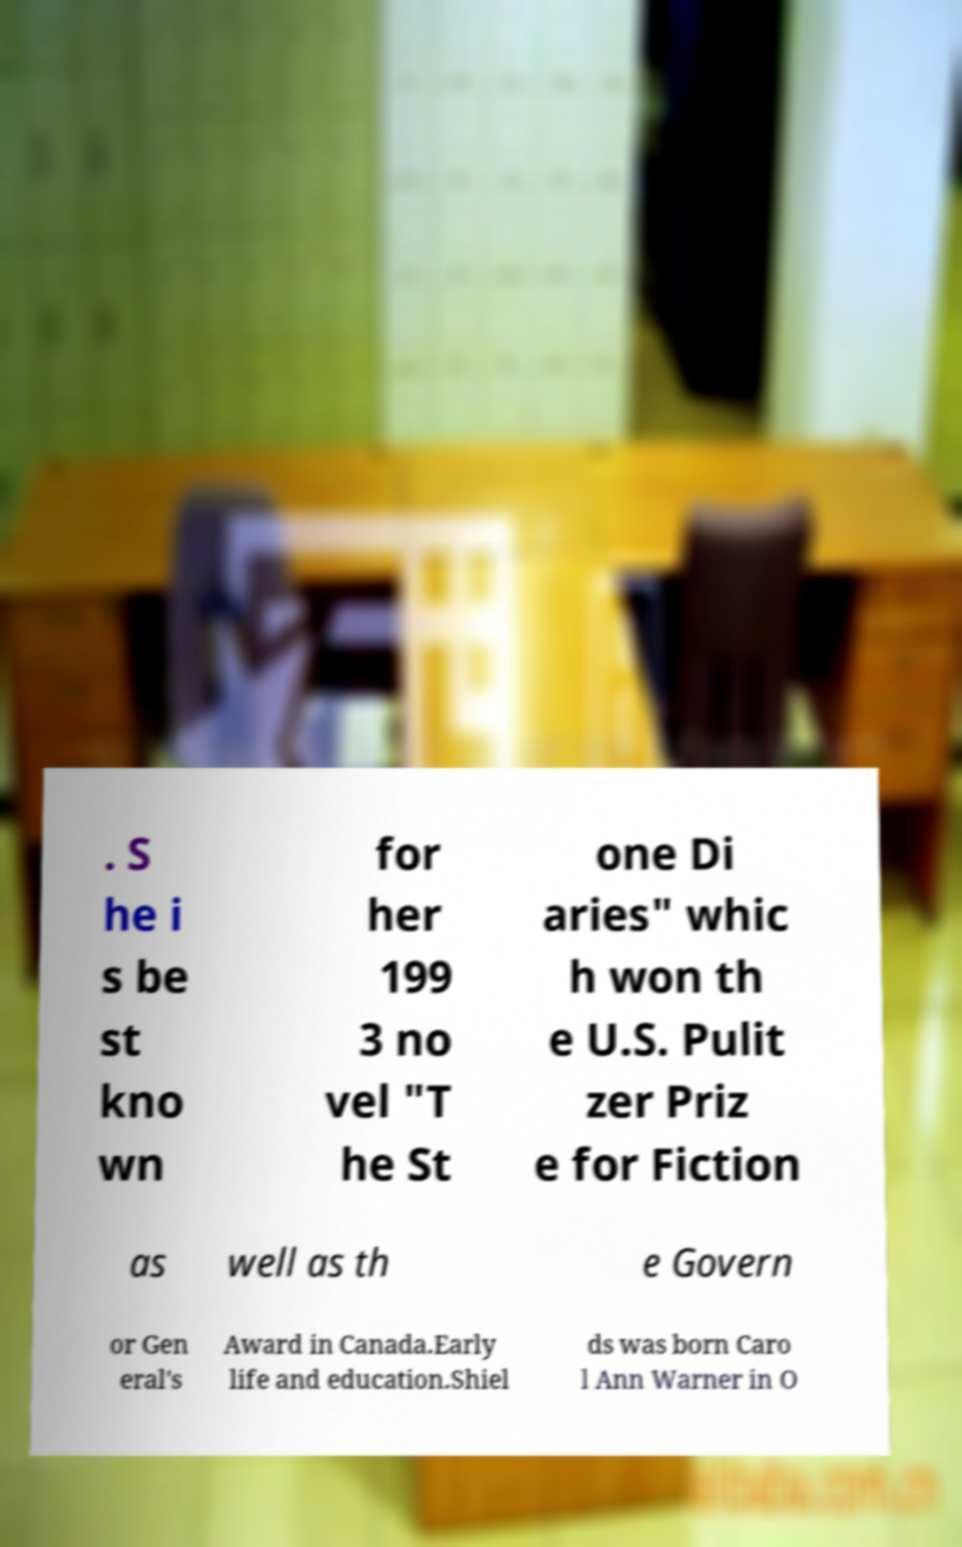What messages or text are displayed in this image? I need them in a readable, typed format. . S he i s be st kno wn for her 199 3 no vel "T he St one Di aries" whic h won th e U.S. Pulit zer Priz e for Fiction as well as th e Govern or Gen eral's Award in Canada.Early life and education.Shiel ds was born Caro l Ann Warner in O 